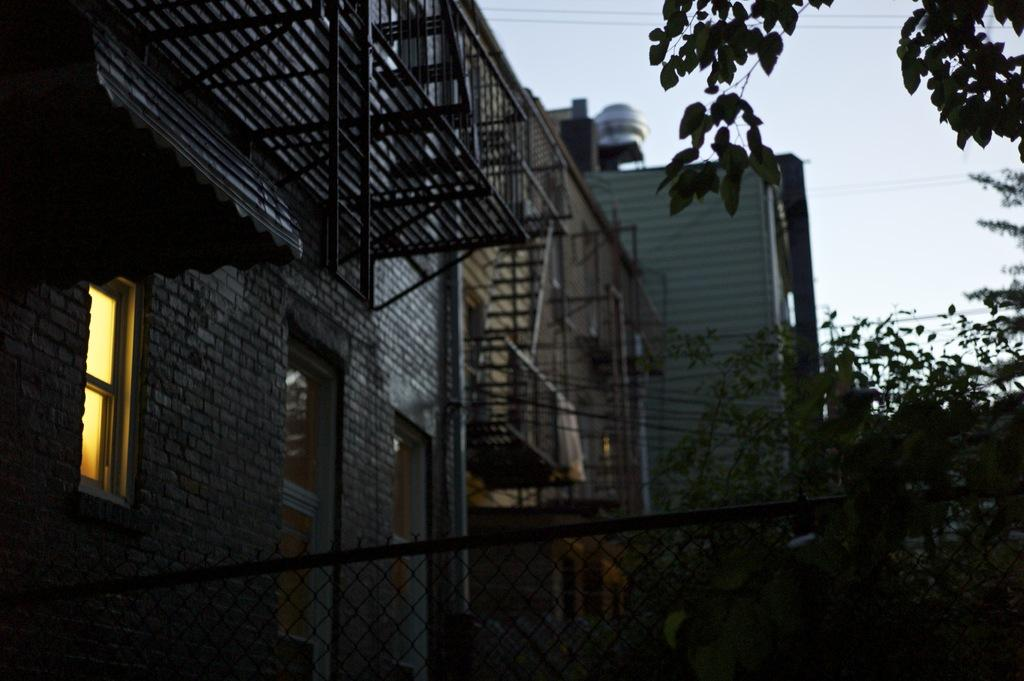What type of material is present in the image? There is mesh in the image. What type of structures can be seen in the image? There are buildings in the image. What type of vegetation is present in the image? Leaves are present in the image. What type of openings can be seen in the image? Windows are visible in the image. What type of utility infrastructure is present in the image? Wires are in the image. What type of safety feature is present in the image? Railings are in the image. What is visible in the background of the image? The sky is visible in the background of the image. How many laborers are working on the scene in the image? There is no scene or laborers present in the image. What type of plastic object can be seen in the image? There is no plastic object present in the image. 